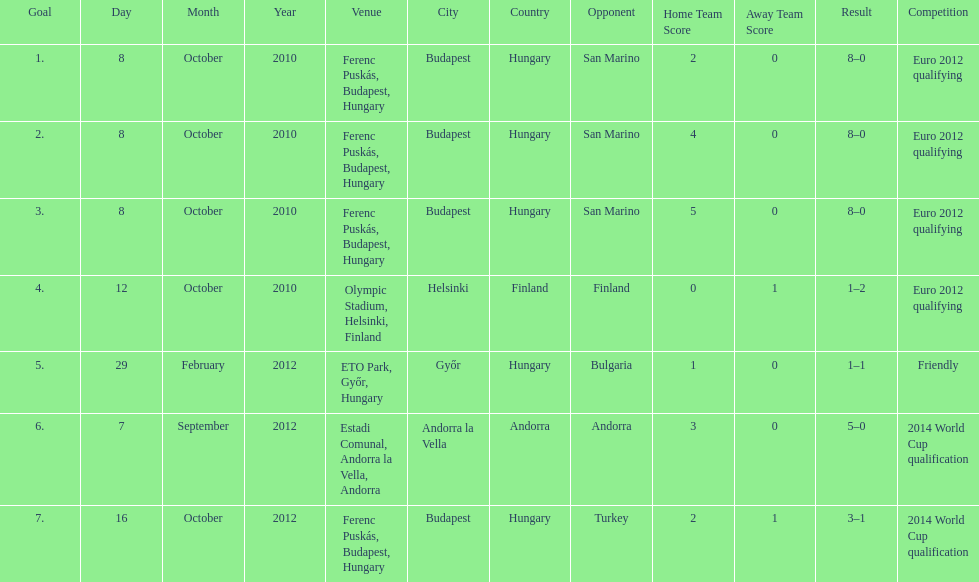Could you parse the entire table? {'header': ['Goal', 'Day', 'Month', 'Year', 'Venue', 'City', 'Country', 'Opponent', 'Home Team Score', 'Away Team Score', 'Result', 'Competition'], 'rows': [['1.', '8', 'October', '2010', 'Ferenc Puskás, Budapest, Hungary', 'Budapest', 'Hungary', 'San Marino', '2', '0', '8–0', 'Euro 2012 qualifying'], ['2.', '8', 'October', '2010', 'Ferenc Puskás, Budapest, Hungary', 'Budapest', 'Hungary', 'San Marino', '4', '0', '8–0', 'Euro 2012 qualifying'], ['3.', '8', 'October', '2010', 'Ferenc Puskás, Budapest, Hungary', 'Budapest', 'Hungary', 'San Marino', '5', '0', '8–0', 'Euro 2012 qualifying'], ['4.', '12', 'October', '2010', 'Olympic Stadium, Helsinki, Finland', 'Helsinki', 'Finland', 'Finland', '0', '1', '1–2', 'Euro 2012 qualifying'], ['5.', '29', 'February', '2012', 'ETO Park, Győr, Hungary', 'Győr', 'Hungary', 'Bulgaria', '1', '0', '1–1', 'Friendly'], ['6.', '7', 'September', '2012', 'Estadi Comunal, Andorra la Vella, Andorra', 'Andorra la Vella', 'Andorra', 'Andorra', '3', '0', '5–0', '2014 World Cup qualification'], ['7.', '16', 'October', '2012', 'Ferenc Puskás, Budapest, Hungary', 'Budapest', 'Hungary', 'Turkey', '2', '1', '3–1', '2014 World Cup qualification']]} How many non-qualifying games did he score in? 1. 